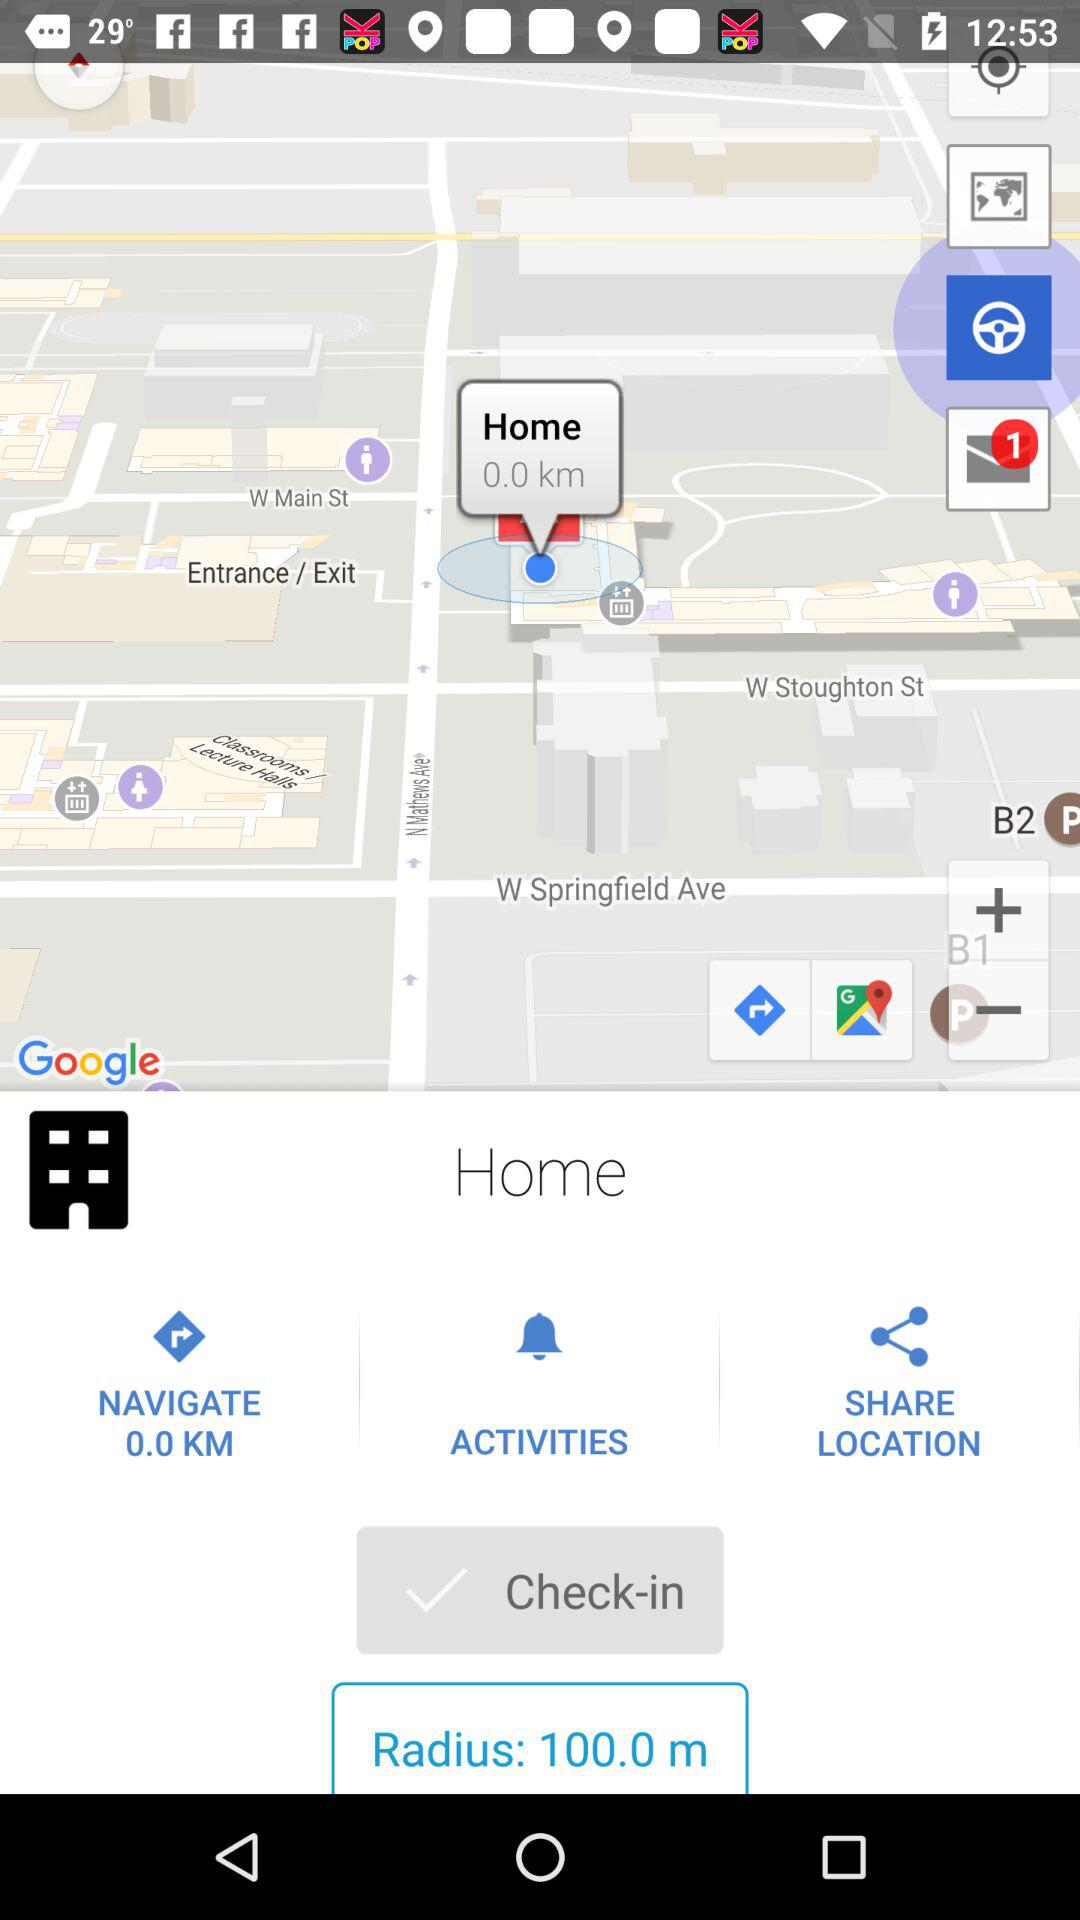How much further away is the destination than the current location?
Answer the question using a single word or phrase. 0.0 km 